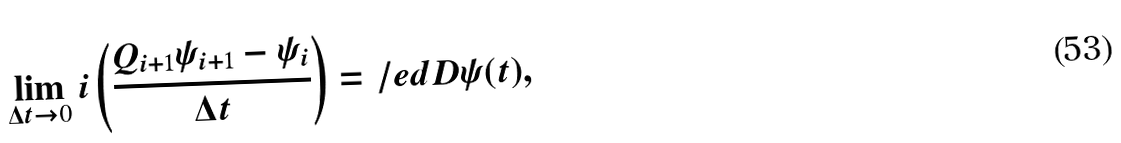Convert formula to latex. <formula><loc_0><loc_0><loc_500><loc_500>\lim _ { \Delta t \rightarrow 0 } i \left ( \frac { Q _ { i + 1 } \psi _ { i + 1 } - \psi _ { i } } { \Delta t } \right ) & = \slash e d { D } \psi ( t ) ,</formula> 